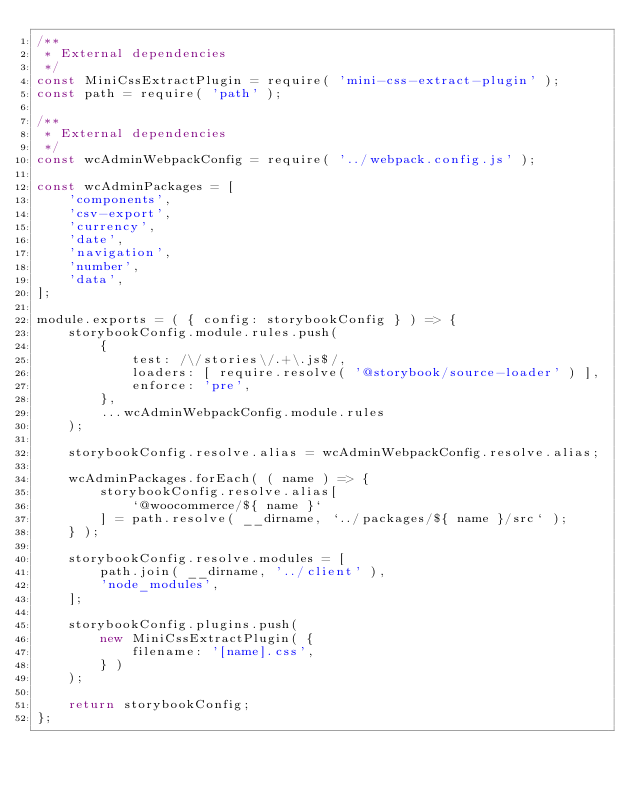Convert code to text. <code><loc_0><loc_0><loc_500><loc_500><_JavaScript_>/**
 * External dependencies
 */
const MiniCssExtractPlugin = require( 'mini-css-extract-plugin' );
const path = require( 'path' );

/**
 * External dependencies
 */
const wcAdminWebpackConfig = require( '../webpack.config.js' );

const wcAdminPackages = [
	'components',
	'csv-export',
	'currency',
	'date',
	'navigation',
	'number',
	'data',
];

module.exports = ( { config: storybookConfig } ) => {
	storybookConfig.module.rules.push(
		{
			test: /\/stories\/.+\.js$/,
			loaders: [ require.resolve( '@storybook/source-loader' ) ],
			enforce: 'pre',
		},
		...wcAdminWebpackConfig.module.rules
	);

	storybookConfig.resolve.alias = wcAdminWebpackConfig.resolve.alias;

	wcAdminPackages.forEach( ( name ) => {
		storybookConfig.resolve.alias[
			`@woocommerce/${ name }`
		] = path.resolve( __dirname, `../packages/${ name }/src` );
	} );

	storybookConfig.resolve.modules = [
		path.join( __dirname, '../client' ),
		'node_modules',
	];

	storybookConfig.plugins.push(
		new MiniCssExtractPlugin( {
			filename: '[name].css',
		} )
	);

	return storybookConfig;
};
</code> 